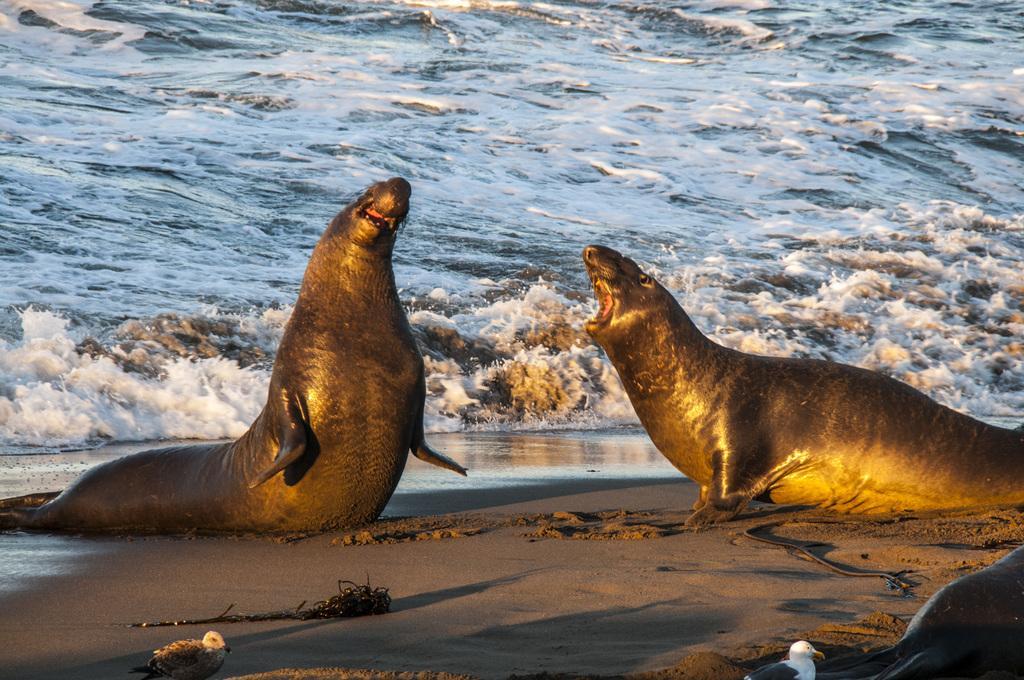How would you summarize this image in a sentence or two? In this image there are two seals, at the bottom there is sand and two birds and in the background there is a beach. 